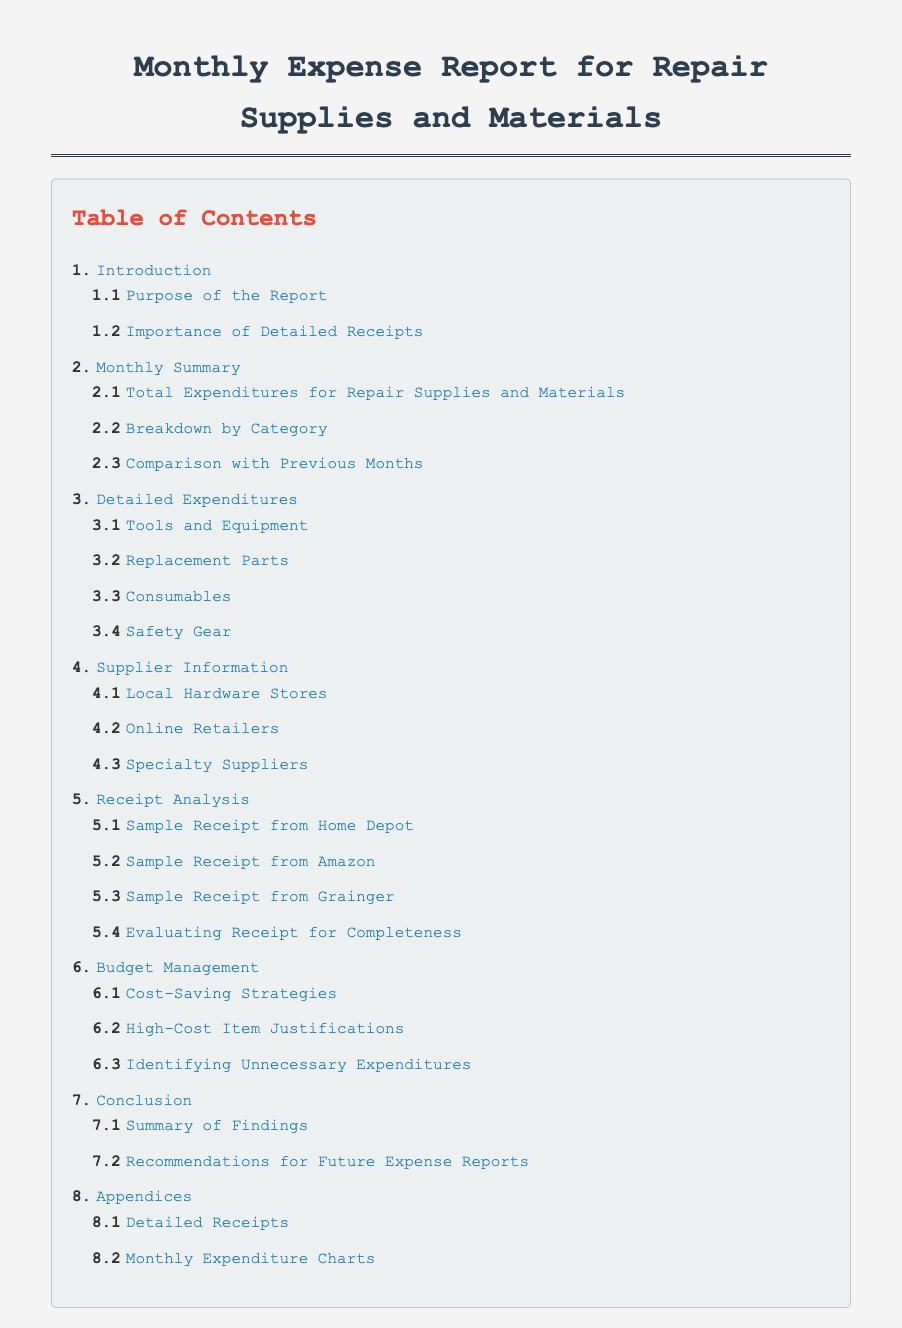What is the title of the document? The title of the document is found in the header of the report, indicating its purpose clearly.
Answer: Monthly Expense Report for Repair Supplies and Materials What section discusses the importance of detailed receipts? This section is outlined under the "Introduction" category, specifically highlighting why detailed receipts are crucial.
Answer: Importance of Detailed Receipts How many sub-sections are under "Detailed Expenditures"? This can be determined by counting the listed sub-sections under that section in the Table of Contents.
Answer: Four What is the purpose of the report? This information is provided in the sub-section under the "Introduction" heading, stating its main aim.
Answer: Purpose of the Report Which major category includes sample receipts? This major category is specifically focused on analyzing receipts from different suppliers.
Answer: Receipt Analysis What information is covered in section 6.2? This points to a specific subsection related to expenditures, particularly addressing expense justifications.
Answer: High-Cost Item Justifications How many suppliers are listed under "Supplier Information"? The number of suppliers can be verified by counting the entries in that specific section.
Answer: Three What is the last section listed in the Table of Contents? The last section is located towards the end, providing additional information or supplemental data.
Answer: Appendices 